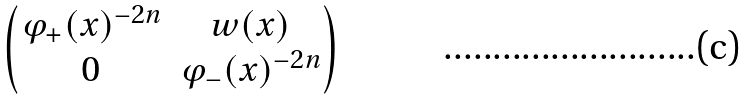<formula> <loc_0><loc_0><loc_500><loc_500>\begin{pmatrix} \varphi _ { + } ( x ) ^ { - 2 n } & w ( x ) \\ 0 & \varphi _ { - } ( x ) ^ { - 2 n } \end{pmatrix}</formula> 